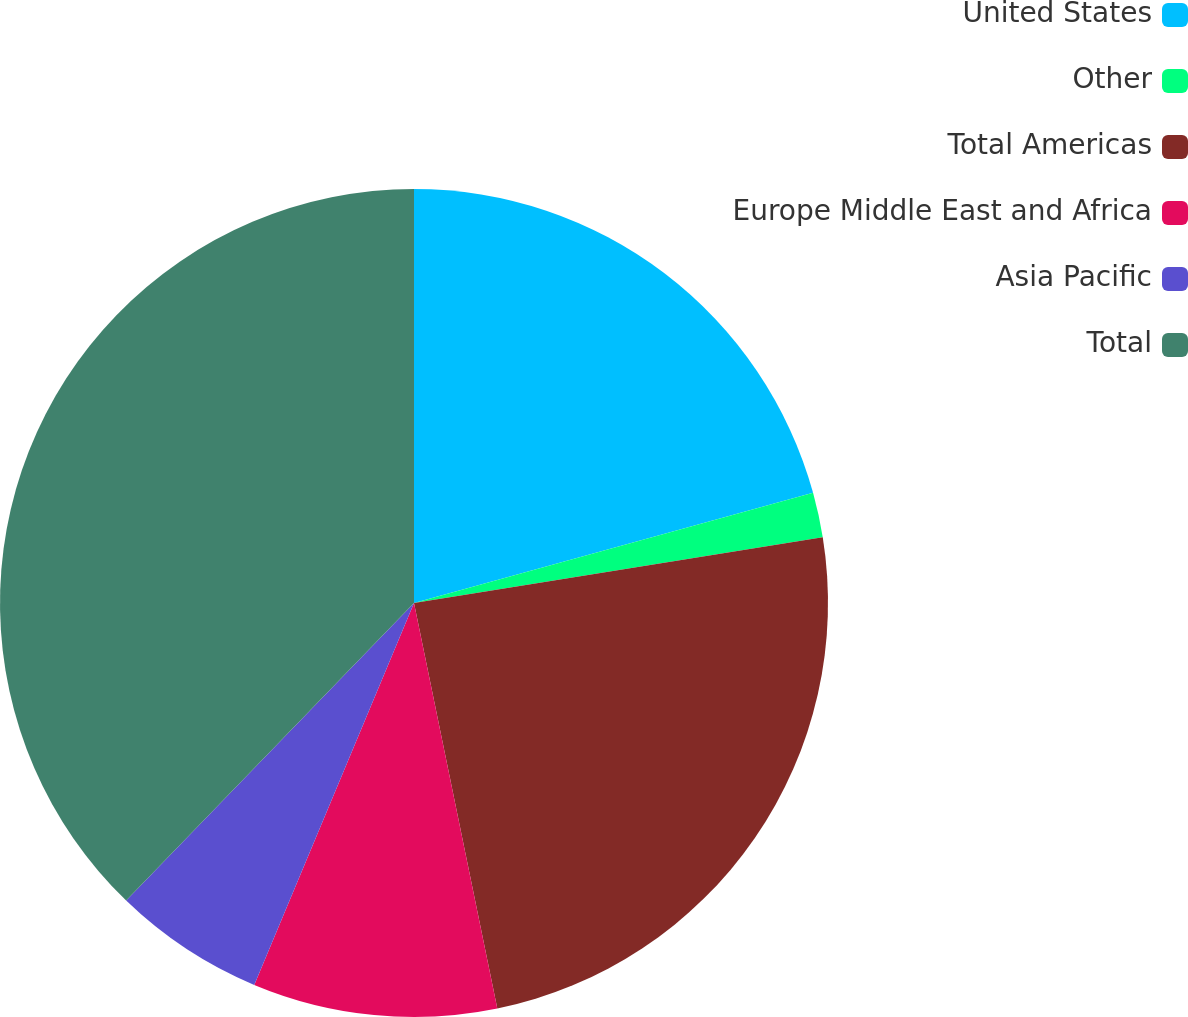<chart> <loc_0><loc_0><loc_500><loc_500><pie_chart><fcel>United States<fcel>Other<fcel>Total Americas<fcel>Europe Middle East and Africa<fcel>Asia Pacific<fcel>Total<nl><fcel>20.71%<fcel>1.75%<fcel>24.31%<fcel>9.53%<fcel>5.93%<fcel>37.76%<nl></chart> 